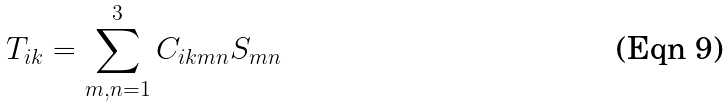Convert formula to latex. <formula><loc_0><loc_0><loc_500><loc_500>T _ { i k } = \sum _ { m , n = 1 } ^ { 3 } C _ { i k m n } S _ { m n }</formula> 